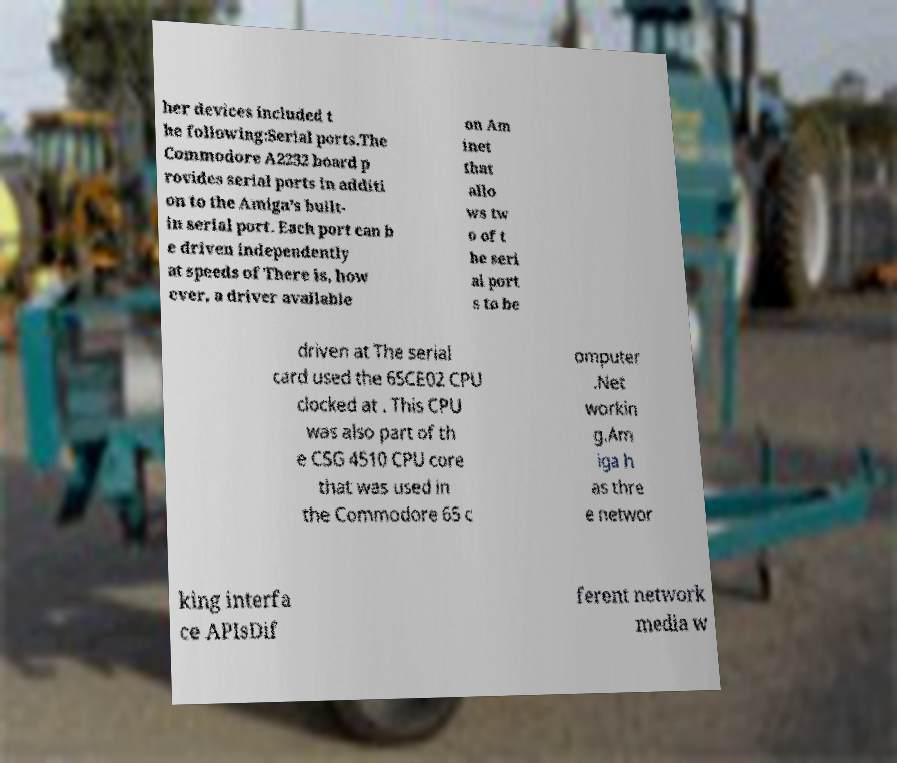I need the written content from this picture converted into text. Can you do that? her devices included t he following:Serial ports.The Commodore A2232 board p rovides serial ports in additi on to the Amiga's built- in serial port. Each port can b e driven independently at speeds of There is, how ever, a driver available on Am inet that allo ws tw o of t he seri al port s to be driven at The serial card used the 65CE02 CPU clocked at . This CPU was also part of th e CSG 4510 CPU core that was used in the Commodore 65 c omputer .Net workin g.Am iga h as thre e networ king interfa ce APIsDif ferent network media w 